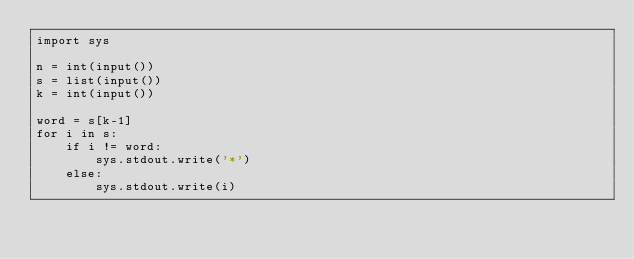<code> <loc_0><loc_0><loc_500><loc_500><_Python_>import sys

n = int(input()) 
s = list(input()) 
k = int(input()) 

word = s[k-1]
for i in s:
    if i != word:
        sys.stdout.write('*')
    else:
        sys.stdout.write(i)</code> 